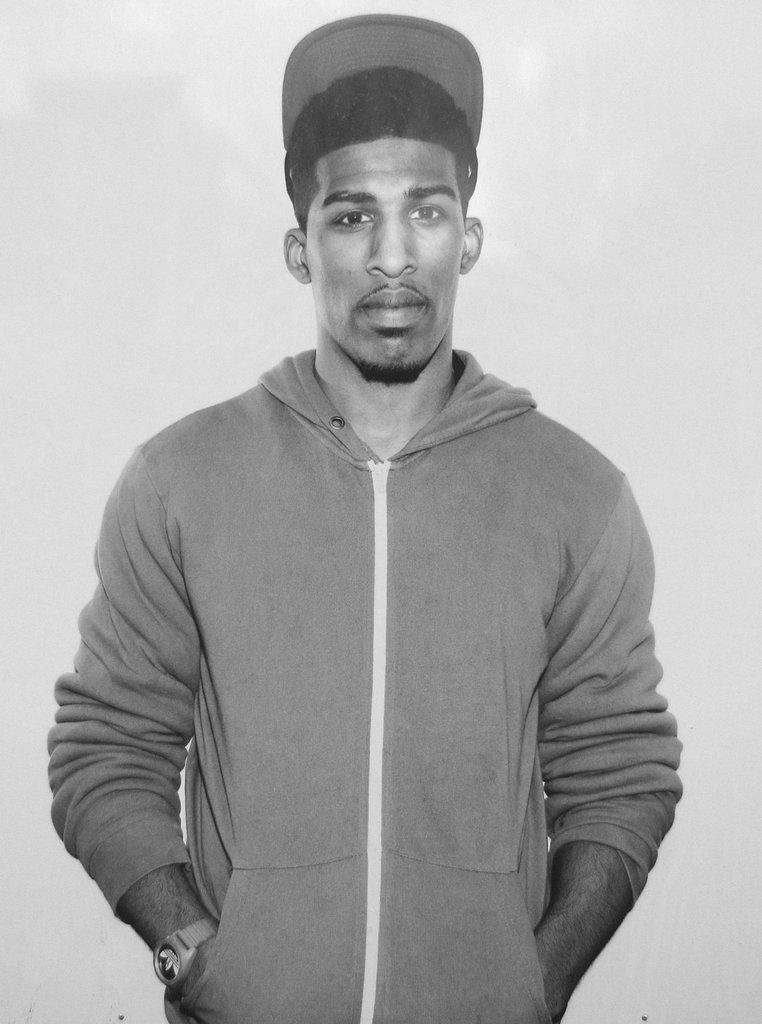What is the main subject of the image? There is a person in the center of the image. What is the person wearing on their head? The person is wearing a hat. What color is the background of the image? The background of the image is white. What type of square is being discussed in the meeting in the image? There is no meeting or square present in the image; it features a person wearing a hat against a white background. What brand of toothpaste is the person using in the image? There is no toothpaste visible in the image, as it only shows a person wearing a hat against a white background. 